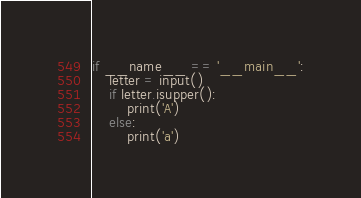<code> <loc_0><loc_0><loc_500><loc_500><_Python_>if __name__ == '__main__':
    letter = input()
    if letter.isupper():
        print('A')
    else:
        print('a')</code> 